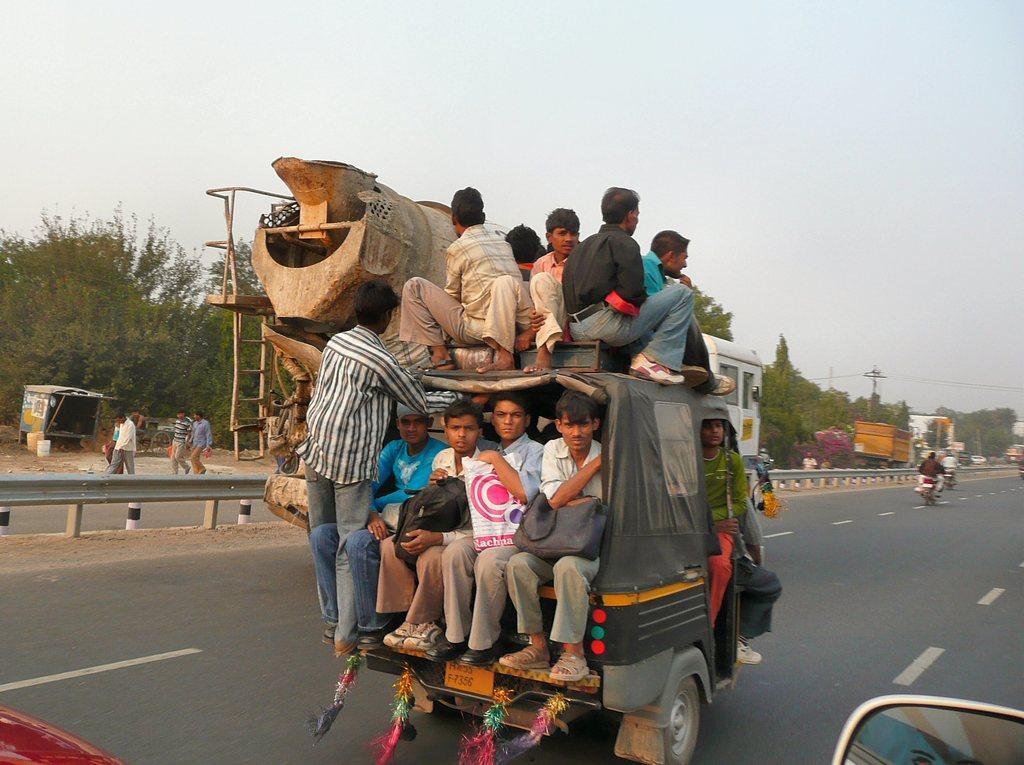Could you give a brief overview of what you see in this image? In this image I can see the road, few vehicles on the road, few persons on the vehicle, few persons in the vehicle, the railing, few persons standing, few trees and few poles. In the background I can see the sky. 